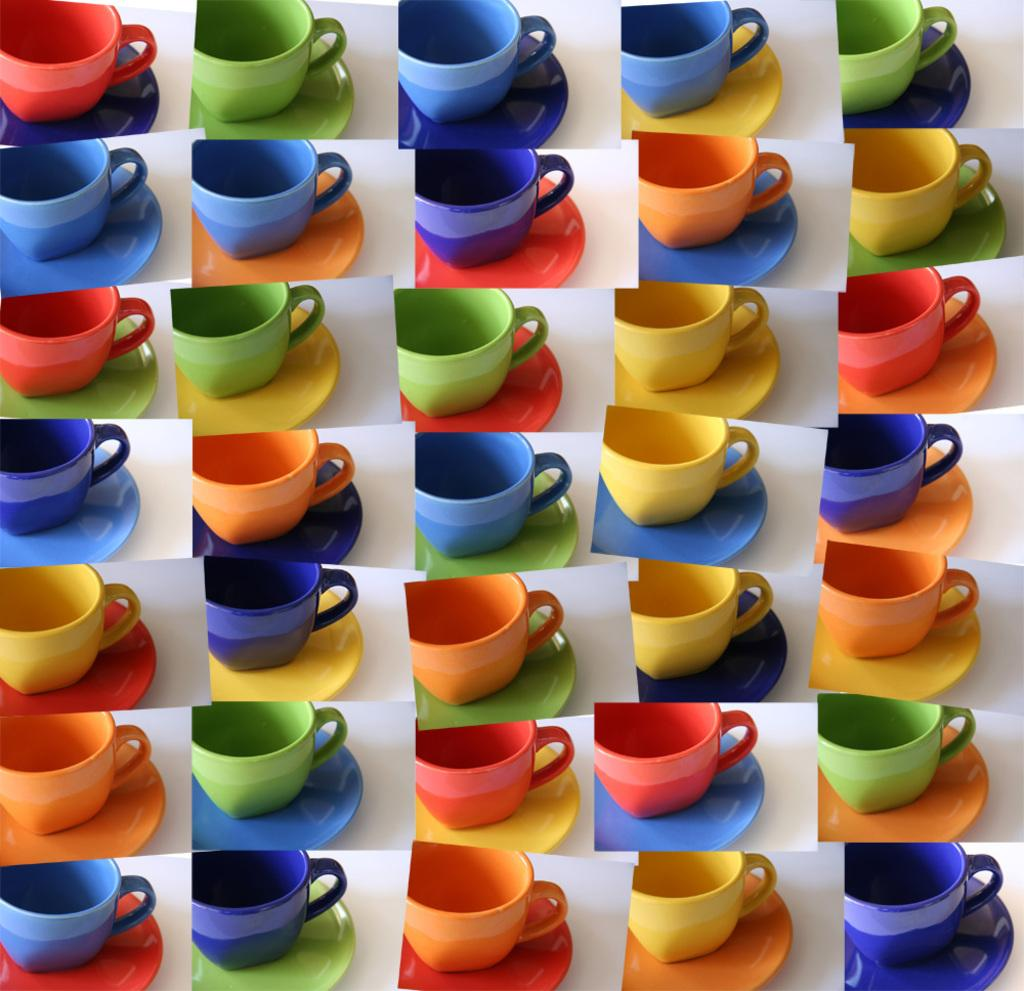What type of artwork is present in the image? The image contains a collage. What objects are featured in the collage? The collage consists of different colorful cups and saucers. Can you see a field of flowers in the image? No, there is no field of flowers present in the image; it features a collage of colorful cups and saucers. Is there any glue visible in the image? The image does not show any glue, as it is a collage of cups and saucers, and glue is typically used to create a collage but not visible in the final product. 